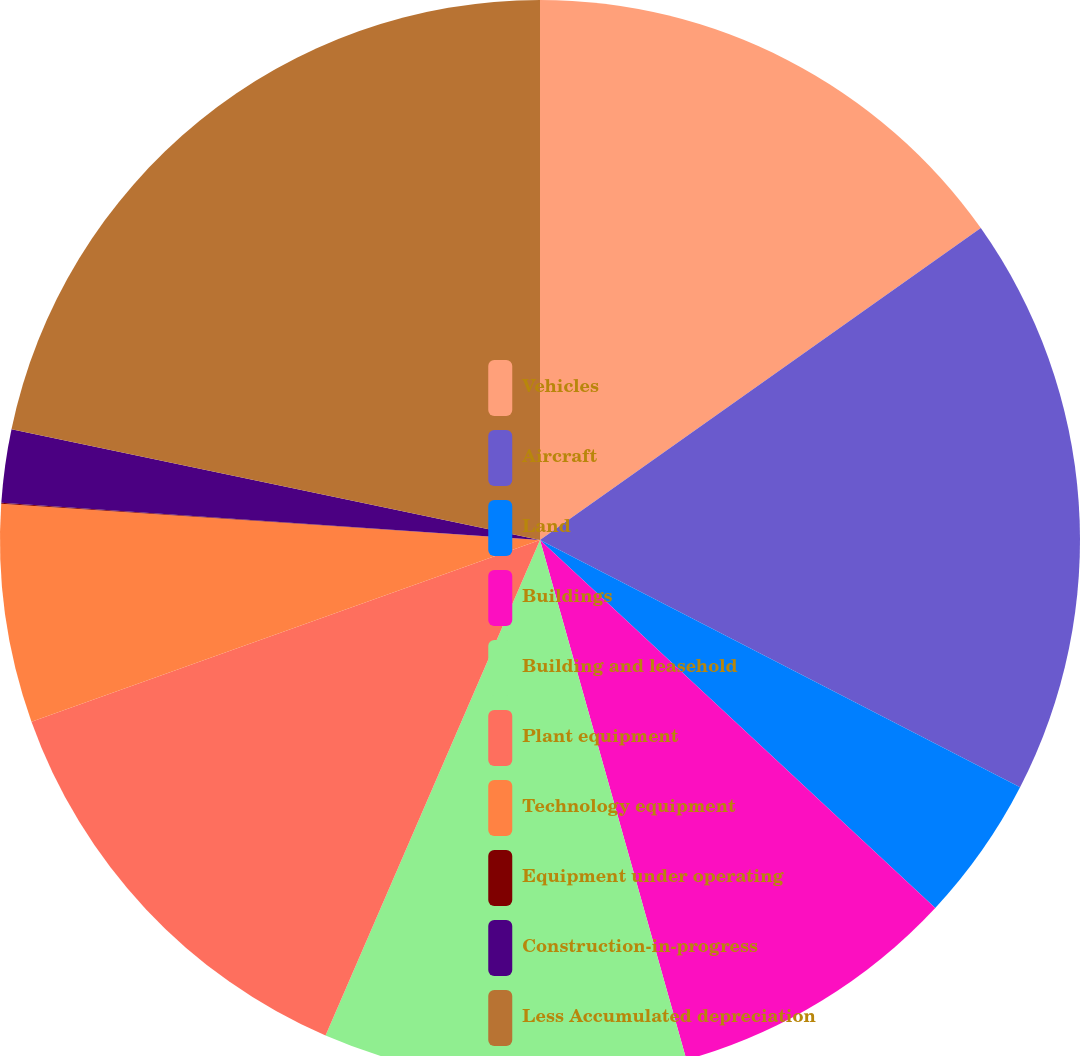<chart> <loc_0><loc_0><loc_500><loc_500><pie_chart><fcel>Vehicles<fcel>Aircraft<fcel>Land<fcel>Buildings<fcel>Building and leasehold<fcel>Plant equipment<fcel>Technology equipment<fcel>Equipment under operating<fcel>Construction-in-progress<fcel>Less Accumulated depreciation<nl><fcel>15.2%<fcel>17.37%<fcel>4.36%<fcel>8.7%<fcel>10.87%<fcel>13.04%<fcel>6.53%<fcel>0.03%<fcel>2.19%<fcel>21.71%<nl></chart> 